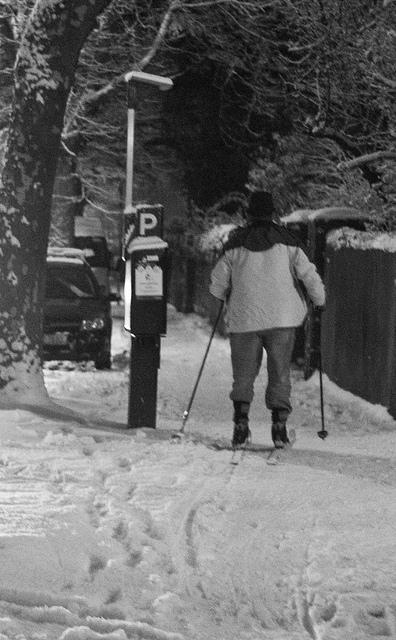What type of area is this? Please explain your reasoning. residential. A person is on the sidewalk and cars are parked with trees lining the street that is not busy. residential areas are not as busy and have more trees than commercial. 